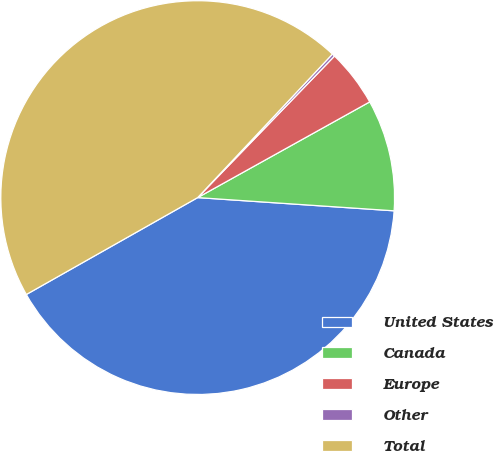Convert chart. <chart><loc_0><loc_0><loc_500><loc_500><pie_chart><fcel>United States<fcel>Canada<fcel>Europe<fcel>Other<fcel>Total<nl><fcel>40.74%<fcel>9.15%<fcel>4.69%<fcel>0.23%<fcel>45.19%<nl></chart> 